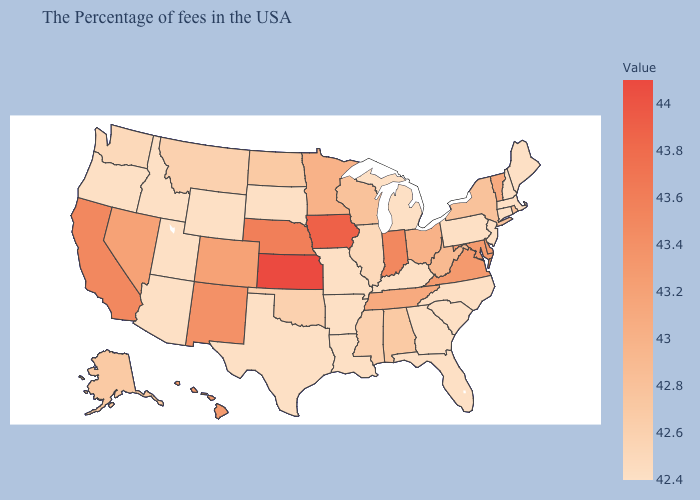Does the map have missing data?
Give a very brief answer. No. Does Alaska have a higher value than Arizona?
Keep it brief. Yes. Which states have the lowest value in the South?
Give a very brief answer. North Carolina, South Carolina, Florida, Georgia, Kentucky, Louisiana, Arkansas, Texas. Among the states that border Louisiana , does Texas have the lowest value?
Answer briefly. Yes. Does Kansas have the lowest value in the USA?
Write a very short answer. No. 